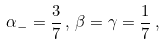Convert formula to latex. <formula><loc_0><loc_0><loc_500><loc_500>\alpha _ { - } = \frac { 3 } { 7 } \, , \, \beta = \gamma = \frac { 1 } { 7 } \, ,</formula> 